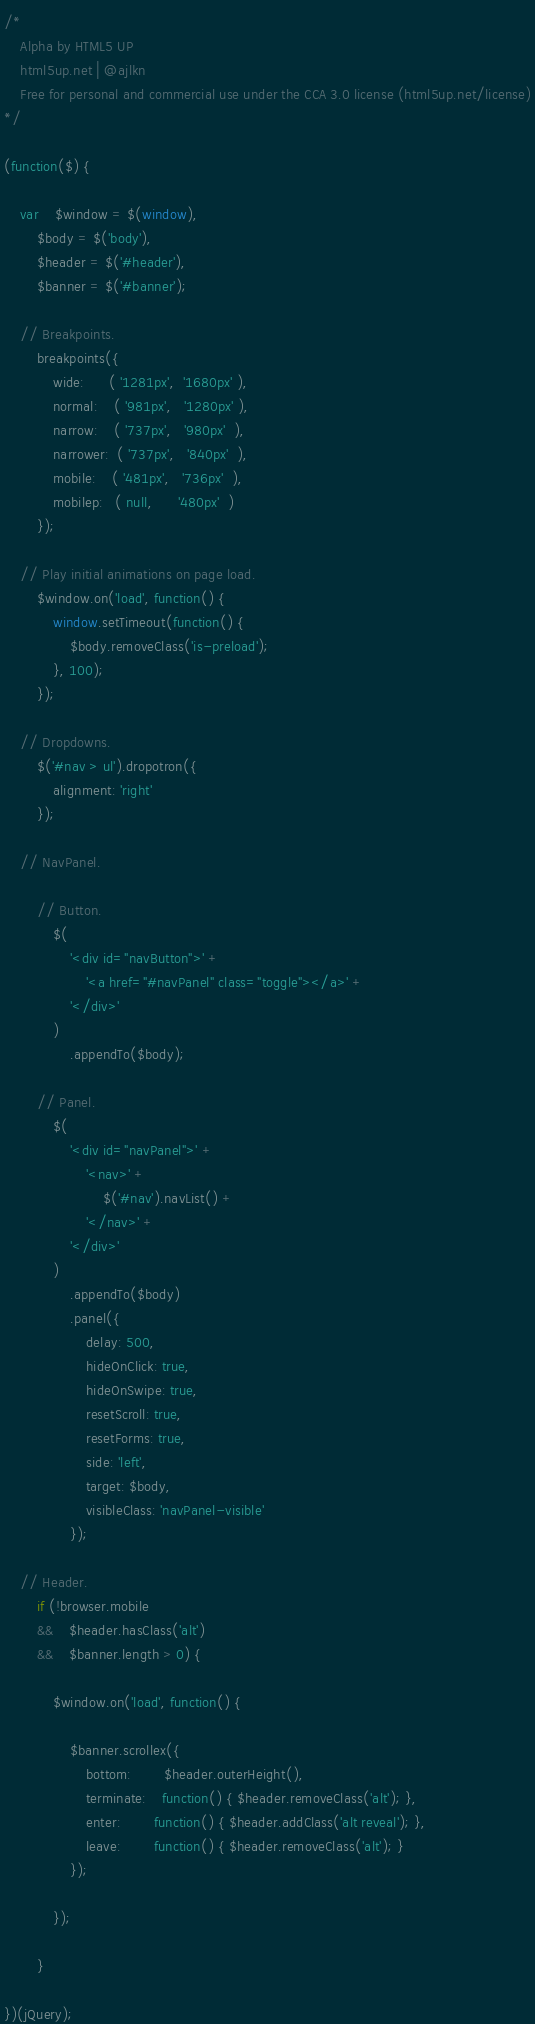<code> <loc_0><loc_0><loc_500><loc_500><_JavaScript_>/*
	Alpha by HTML5 UP
	html5up.net | @ajlkn
	Free for personal and commercial use under the CCA 3.0 license (html5up.net/license)
*/

(function($) { 

	var	$window = $(window),
		$body = $('body'),
		$header = $('#header'),
		$banner = $('#banner');

	// Breakpoints.
		breakpoints({
			wide:      ( '1281px',  '1680px' ),
			normal:    ( '981px',   '1280px' ),
			narrow:    ( '737px',   '980px'  ),
			narrower:  ( '737px',   '840px'  ),
			mobile:    ( '481px',   '736px'  ),
			mobilep:   ( null,      '480px'  )
		});

	// Play initial animations on page load.
		$window.on('load', function() {
			window.setTimeout(function() {
				$body.removeClass('is-preload');
			}, 100);
		});

	// Dropdowns.
		$('#nav > ul').dropotron({
			alignment: 'right'
		});

	// NavPanel.

		// Button.
			$(
				'<div id="navButton">' +
					'<a href="#navPanel" class="toggle"></a>' +
				'</div>'
			)
				.appendTo($body);

		// Panel.
			$(
				'<div id="navPanel">' +
					'<nav>' +
						$('#nav').navList() +
					'</nav>' +
				'</div>'
			)
				.appendTo($body)
				.panel({
					delay: 500,
					hideOnClick: true,
					hideOnSwipe: true,
					resetScroll: true,
					resetForms: true,
					side: 'left',
					target: $body,
					visibleClass: 'navPanel-visible'
				});

	// Header.
		if (!browser.mobile
		&&	$header.hasClass('alt')
		&&	$banner.length > 0) {

			$window.on('load', function() {

				$banner.scrollex({
					bottom:		$header.outerHeight(),
					terminate:	function() { $header.removeClass('alt'); },
					enter:		function() { $header.addClass('alt reveal'); },
					leave:		function() { $header.removeClass('alt'); }
				});

			});

		}

})(jQuery);

</code> 